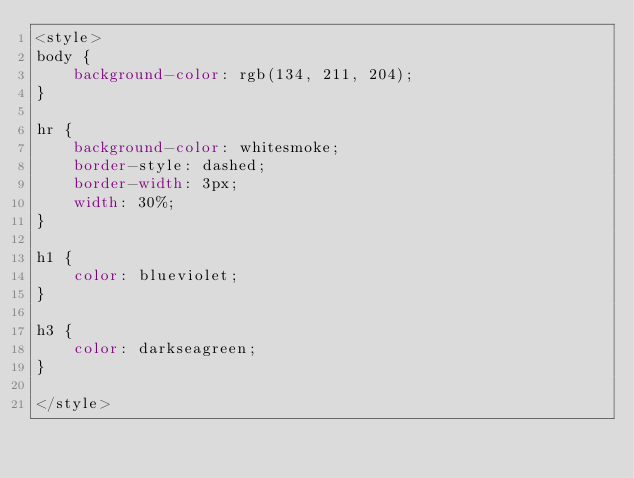<code> <loc_0><loc_0><loc_500><loc_500><_CSS_><style>
body {
    background-color: rgb(134, 211, 204);
}

hr {
    background-color: whitesmoke;
    border-style: dashed;
    border-width: 3px;
    width: 30%;
}

h1 {
    color: blueviolet;
}

h3 {
    color: darkseagreen;
}

</style></code> 